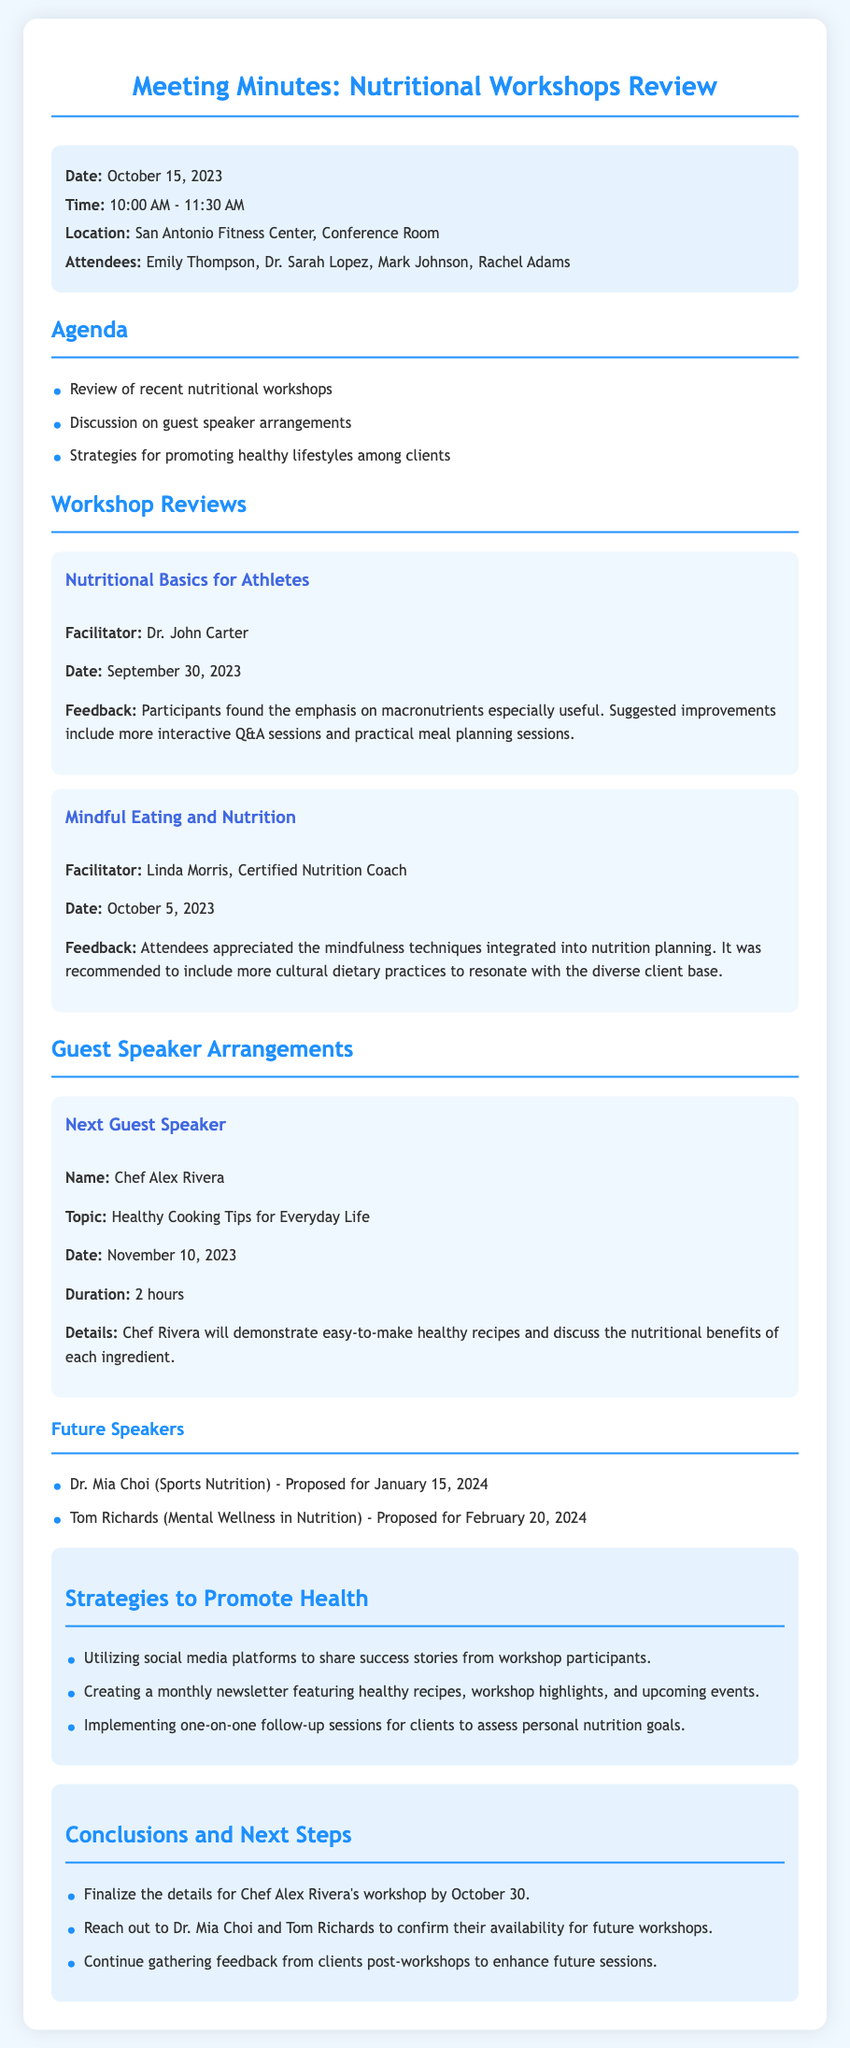What was the date of the meeting? The meeting date is specified in the meta-info section of the document.
Answer: October 15, 2023 Who facilitated the workshop on Mindful Eating and Nutrition? The facilitator's name is provided in the workshop reviews section.
Answer: Linda Morris, Certified Nutrition Coach What is the topic of the next guest speaker? The topic is listed under the Guest Speaker Arrangements section of the document.
Answer: Healthy Cooking Tips for Everyday Life When is Chef Alex Rivera's workshop scheduled? The date is mentioned in the Guest Speaker Arrangements section.
Answer: November 10, 2023 What strategies were discussed to promote health? The strategies are outlined in the respective section of the document.
Answer: Utilizing social media platforms to share success stories from workshop participants What feedback was received for Nutritional Basics for Athletes? Specific feedback is provided under the Workshop Reviews section.
Answer: Participants found the emphasis on macronutrients especially useful How long is the next guest speaker's presentation? The duration is explicitly mentioned in the document.
Answer: 2 hours What is one of the future speaker's names and topics? The names and topics of future speakers are listed in the guest speaker arrangements section.
Answer: Dr. Mia Choi (Sports Nutrition) 